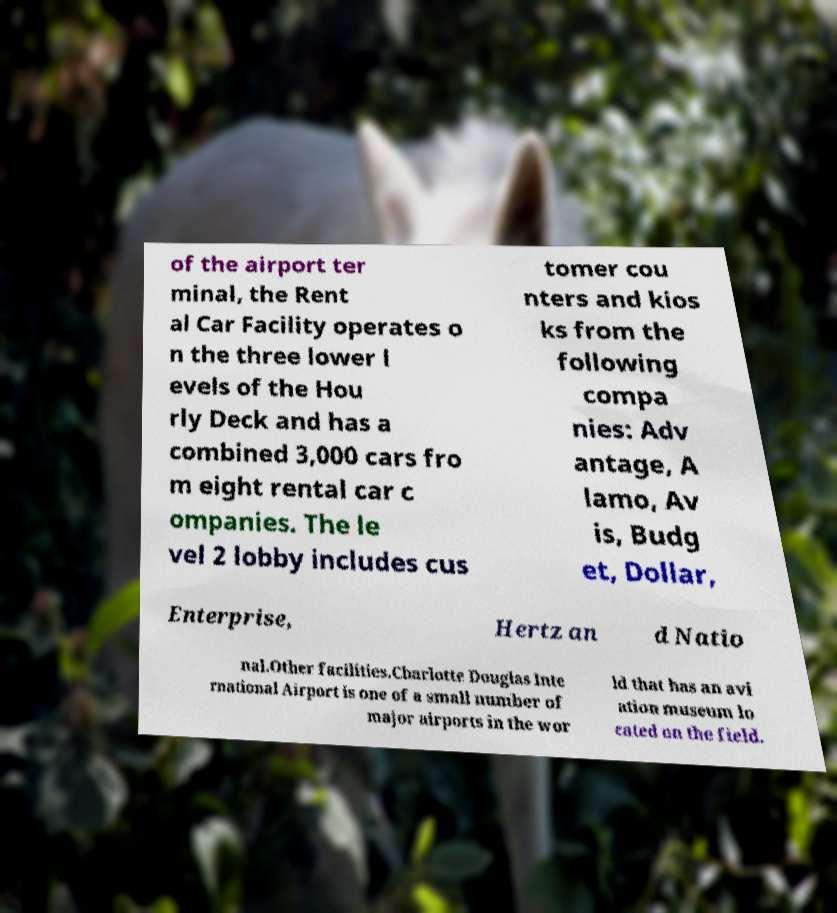Please read and relay the text visible in this image. What does it say? of the airport ter minal, the Rent al Car Facility operates o n the three lower l evels of the Hou rly Deck and has a combined 3,000 cars fro m eight rental car c ompanies. The le vel 2 lobby includes cus tomer cou nters and kios ks from the following compa nies: Adv antage, A lamo, Av is, Budg et, Dollar, Enterprise, Hertz an d Natio nal.Other facilities.Charlotte Douglas Inte rnational Airport is one of a small number of major airports in the wor ld that has an avi ation museum lo cated on the field. 